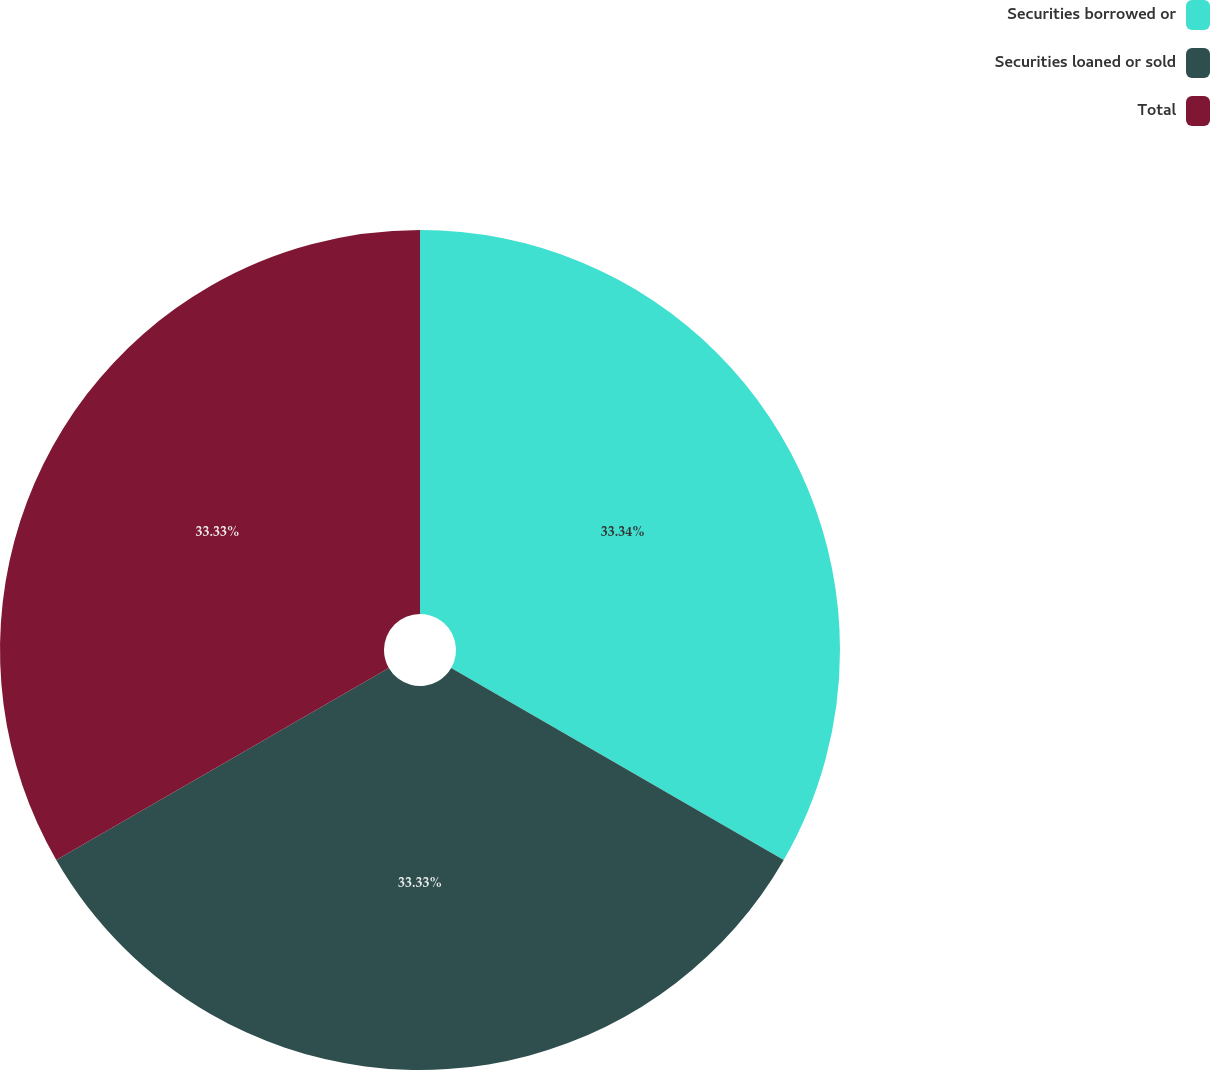Convert chart. <chart><loc_0><loc_0><loc_500><loc_500><pie_chart><fcel>Securities borrowed or<fcel>Securities loaned or sold<fcel>Total<nl><fcel>33.33%<fcel>33.33%<fcel>33.33%<nl></chart> 